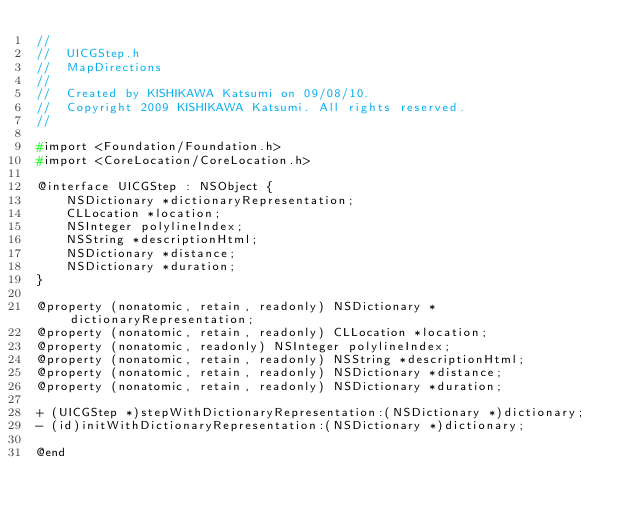<code> <loc_0><loc_0><loc_500><loc_500><_C_>//
//  UICGStep.h
//  MapDirections
//
//  Created by KISHIKAWA Katsumi on 09/08/10.
//  Copyright 2009 KISHIKAWA Katsumi. All rights reserved.
//

#import <Foundation/Foundation.h>
#import <CoreLocation/CoreLocation.h>

@interface UICGStep : NSObject {
	NSDictionary *dictionaryRepresentation;
	CLLocation *location;
	NSInteger polylineIndex;
	NSString *descriptionHtml;
	NSDictionary *distance;
	NSDictionary *duration;
}

@property (nonatomic, retain, readonly) NSDictionary *dictionaryRepresentation;
@property (nonatomic, retain, readonly) CLLocation *location;
@property (nonatomic, readonly) NSInteger polylineIndex;
@property (nonatomic, retain, readonly) NSString *descriptionHtml;
@property (nonatomic, retain, readonly) NSDictionary *distance;
@property (nonatomic, retain, readonly) NSDictionary *duration;

+ (UICGStep *)stepWithDictionaryRepresentation:(NSDictionary *)dictionary;
- (id)initWithDictionaryRepresentation:(NSDictionary *)dictionary;

@end
</code> 